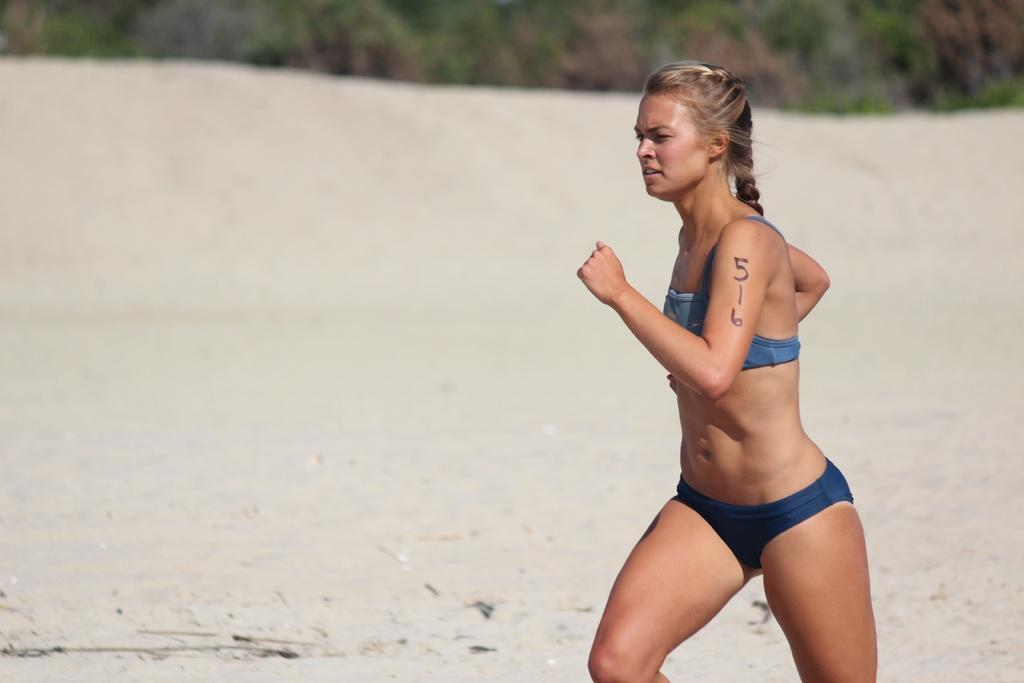What is the woman in the image doing? The woman is running in the image. What type of surface is the woman running on? There is sand at the bottom of the image, so the woman is running on sand. What can be seen in the background of the image? There are trees in the background of the image. What color is the ant's brain in the image? There is no ant present in the image, so it is not possible to determine the color of its brain. 